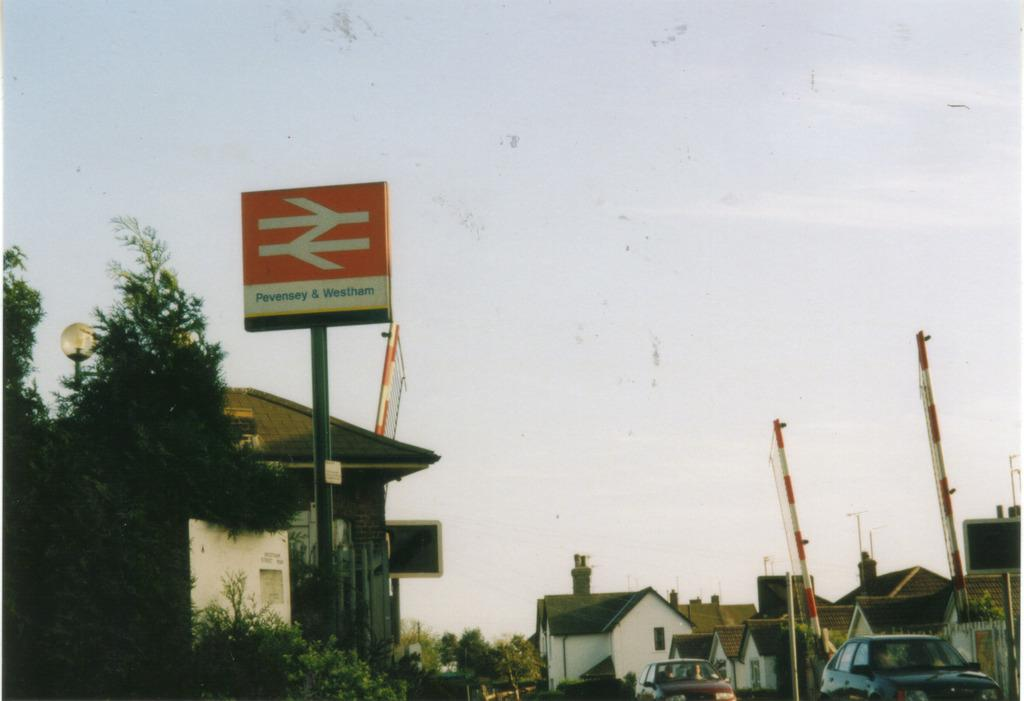What type of structures can be seen in the image? There are houses in the image. What else can be seen moving in the image? There are vehicles in the image. What are the signs that indicate the names of places or businesses in the image? Name boards are present in the image. What is the source of light visible at night in the image? A street light is visible in the image. What are the long, thin objects supporting the wires in the image? Poles are present in the image. What type of vegetation can be seen in the image? Trees are visible in the image. What are the unidentified objects in the image? There are some objects in the image. What can be seen in the background of the image? The sky is visible in the background of the image. Can you see a tiger walking on the street in the image? No, there is no tiger present in the image. What type of bird can be seen singing on the street light in the image? There are no birds visible in the image, let alone singing on the street light. 